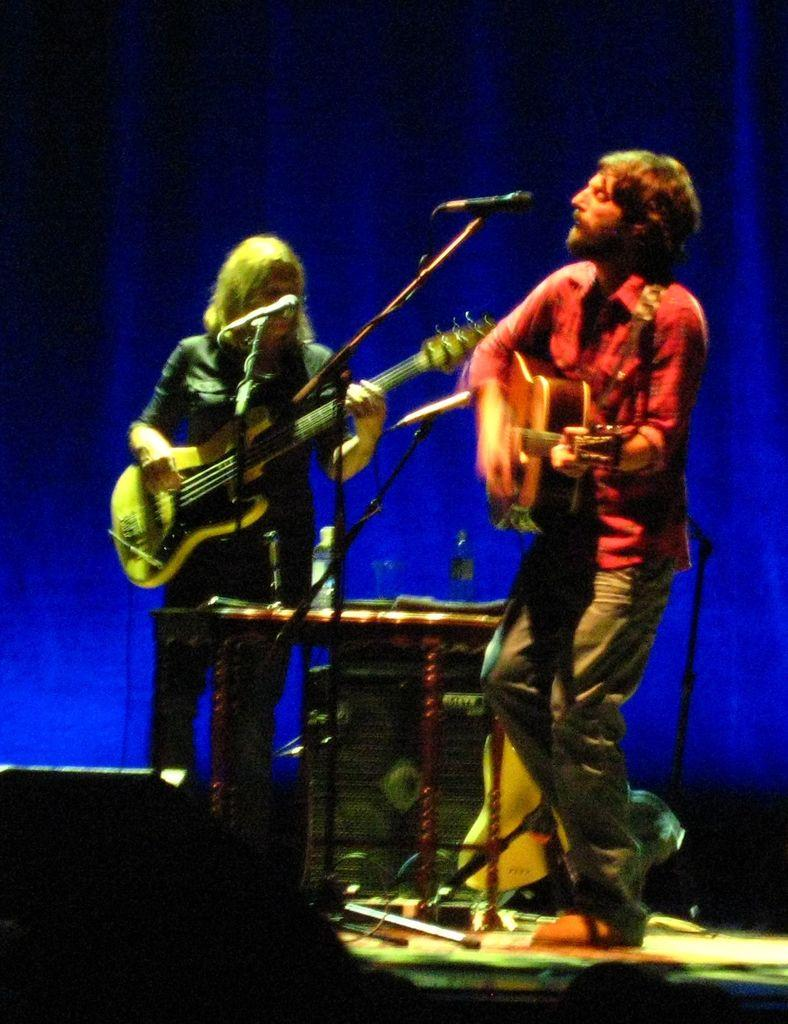How many people are in the image? There are two people in the image. What are the two people doing in the image? The two people are playing musical instruments. Can you describe any equipment related to music in the image? Yes, there is a microphone in the image. What else can be seen in the image that is related to music? There are musical stuff around the people. What type of engine can be seen powering the musical instruments in the image? There is no engine present in the image, and the musical instruments are not powered by an engine. 